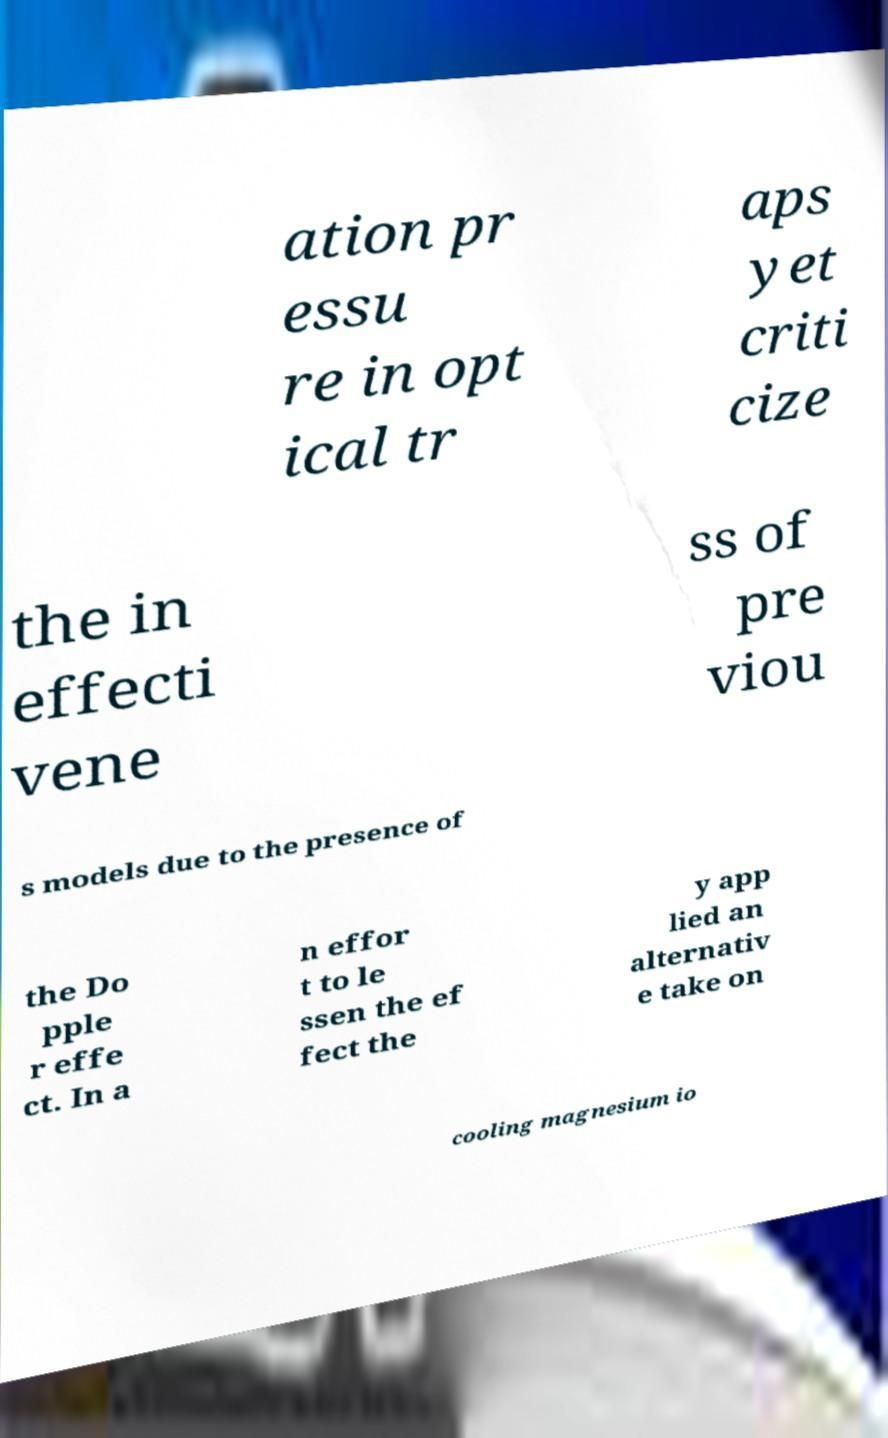There's text embedded in this image that I need extracted. Can you transcribe it verbatim? ation pr essu re in opt ical tr aps yet criti cize the in effecti vene ss of pre viou s models due to the presence of the Do pple r effe ct. In a n effor t to le ssen the ef fect the y app lied an alternativ e take on cooling magnesium io 